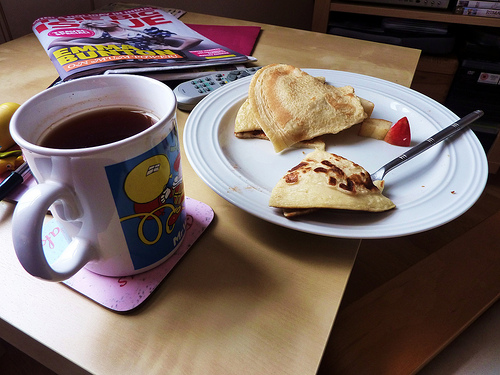<image>
Is the food next to the drink? Yes. The food is positioned adjacent to the drink, located nearby in the same general area. 